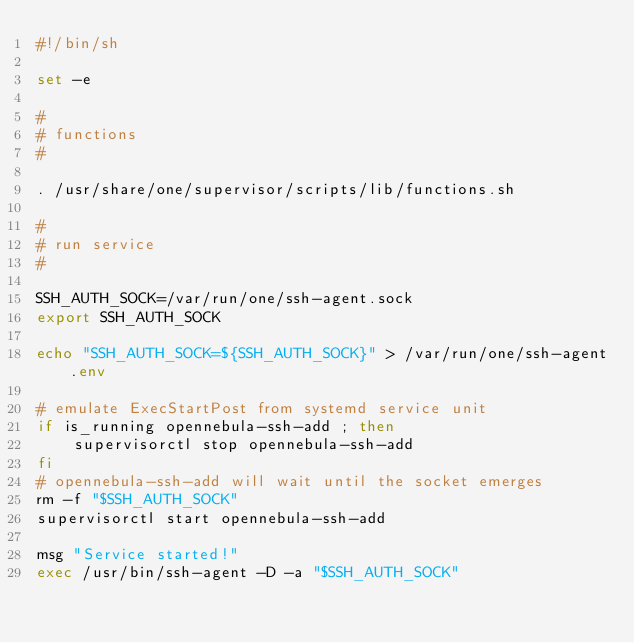Convert code to text. <code><loc_0><loc_0><loc_500><loc_500><_Bash_>#!/bin/sh

set -e

#
# functions
#

. /usr/share/one/supervisor/scripts/lib/functions.sh

#
# run service
#

SSH_AUTH_SOCK=/var/run/one/ssh-agent.sock
export SSH_AUTH_SOCK

echo "SSH_AUTH_SOCK=${SSH_AUTH_SOCK}" > /var/run/one/ssh-agent.env

# emulate ExecStartPost from systemd service unit
if is_running opennebula-ssh-add ; then
    supervisorctl stop opennebula-ssh-add
fi
# opennebula-ssh-add will wait until the socket emerges
rm -f "$SSH_AUTH_SOCK"
supervisorctl start opennebula-ssh-add

msg "Service started!"
exec /usr/bin/ssh-agent -D -a "$SSH_AUTH_SOCK"
</code> 